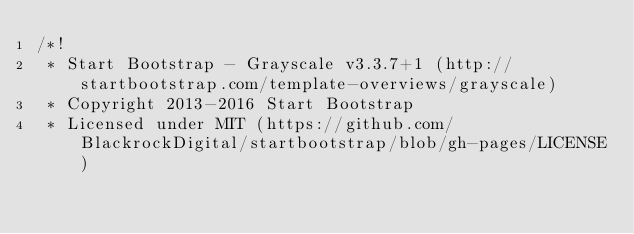Convert code to text. <code><loc_0><loc_0><loc_500><loc_500><_CSS_>/*!
 * Start Bootstrap - Grayscale v3.3.7+1 (http://startbootstrap.com/template-overviews/grayscale)
 * Copyright 2013-2016 Start Bootstrap
 * Licensed under MIT (https://github.com/BlackrockDigital/startbootstrap/blob/gh-pages/LICENSE)</code> 